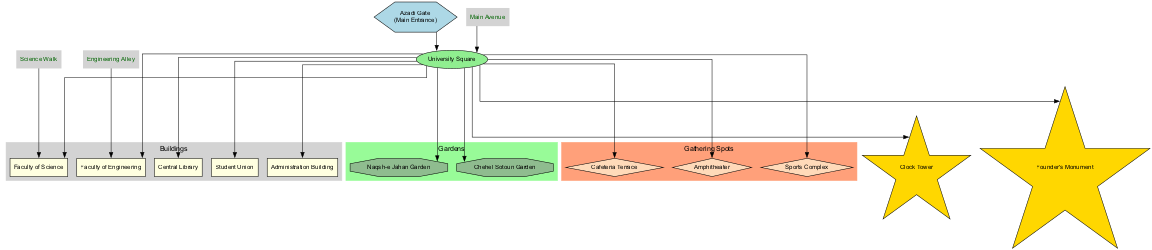What is the main entrance of the campus? The diagram indicates that the main entrance is labeled as "Azadi Gate," which is clearly marked within the layout.
Answer: Azadi Gate How many buildings are highlighted in the diagram? By counting the entries in the "Buildings" section of the diagram, it can be determined that there are five buildings shown.
Answer: 5 Which garden is named after a historical site? The "Naqsh-e Jahan Garden" is named after a famous historical site, making it distinctive among the gardens in the diagram.
Answer: Naqsh-e Jahan Garden What is the shape of the Central Library node? The Central Library is depicted as a rectangle in the diagram, which is the standard shape used for buildings in this layout.
Answer: Rectangle Which two paths are connected to the Faculty of Science? The 'Science Walk' is directly linked to the Faculty of Science, and 'Main Avenue' connects to the central square where the Faculty of Science is located. Since "Main Avenue" also leads to the square, it indirectly connects as well.
Answer: Science Walk, Main Avenue What type of shapes are used for gathering spots? The gathering spots are represented with diamond shapes according to the diagram's depiction of these areas, which is typical for areas designed for group activities.
Answer: Diamond Which landmark is located nearest to the University Square? Looking at the connections from the University Square, the "Clock Tower" is one of the landmarks very close, as it connects directly to the central square shown.
Answer: Clock Tower How many gathering spots are indicated on the diagram? The diagram lists three gathering spots in total, as seen in the section dedicated to gathering areas.
Answer: 3 Which buildings are adjacent to the University Square? The buildings adjacent to the University Square include the Faculty of Engineering, Faculty of Science, Central Library, Student Union, and Administration Building, all of which connect directly to the square.
Answer: Faculty of Engineering, Faculty of Science, Central Library, Student Union, Administration Building 